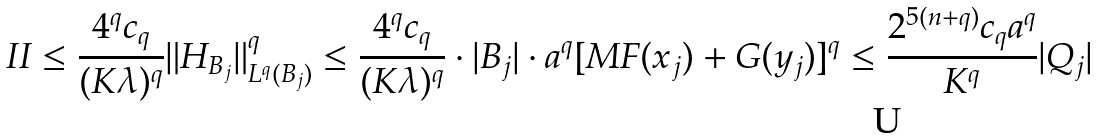Convert formula to latex. <formula><loc_0><loc_0><loc_500><loc_500>I I \leq \frac { 4 ^ { q } c _ { q } } { ( K \lambda ) ^ { q } } \| H _ { B _ { j } } \| _ { L ^ { q } ( B _ { j } ) } ^ { q } \leq \frac { 4 ^ { q } c _ { q } } { ( K \lambda ) ^ { q } } \cdot | B _ { j } | \cdot a ^ { q } [ M F ( x _ { j } ) + G ( y _ { j } ) ] ^ { q } \leq \frac { 2 ^ { 5 ( n + q ) } c _ { q } a ^ { q } } { K ^ { q } } | Q _ { j } |</formula> 